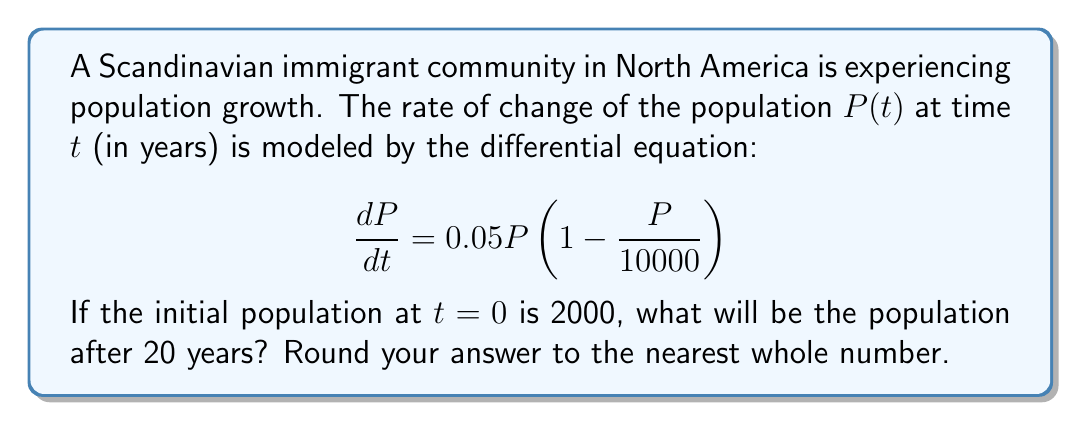Give your solution to this math problem. To solve this problem, we need to use the logistic growth model, which is represented by the given differential equation. Let's solve it step by step:

1) The general solution for the logistic growth model is:

   $$P(t) = \frac{K}{1 + (\frac{K}{P_0} - 1)e^{-rt}}$$

   Where:
   K is the carrying capacity (10000 in this case)
   r is the growth rate (0.05 in this case)
   $P_0$ is the initial population (2000 in this case)

2) Substituting these values into the equation:

   $$P(t) = \frac{10000}{1 + (\frac{10000}{2000} - 1)e^{-0.05t}}$$

3) Simplify:

   $$P(t) = \frac{10000}{1 + 4e^{-0.05t}}$$

4) Now, we want to find P(20), so we substitute t = 20:

   $$P(20) = \frac{10000}{1 + 4e^{-0.05(20)}}$$

5) Calculate:

   $$P(20) = \frac{10000}{1 + 4e^{-1}}$$
   
   $$P(20) = \frac{10000}{1 + 4(0.3679)}$$
   
   $$P(20) = \frac{10000}{2.4716}$$
   
   $$P(20) = 4046.37$$

6) Rounding to the nearest whole number:

   P(20) ≈ 4046
Answer: 4046 